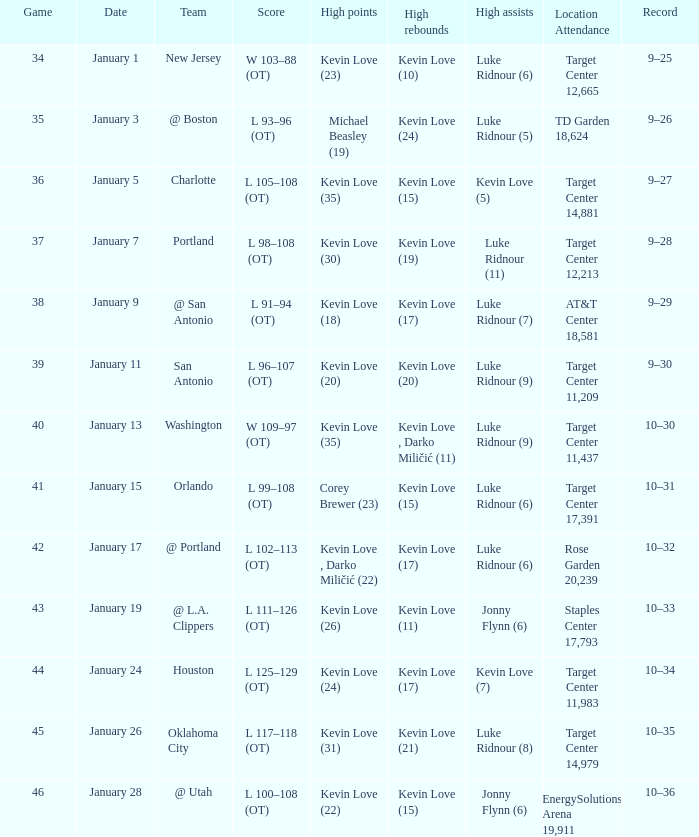What is the highest-scoring game involving the l.a. clippers team? 43.0. 